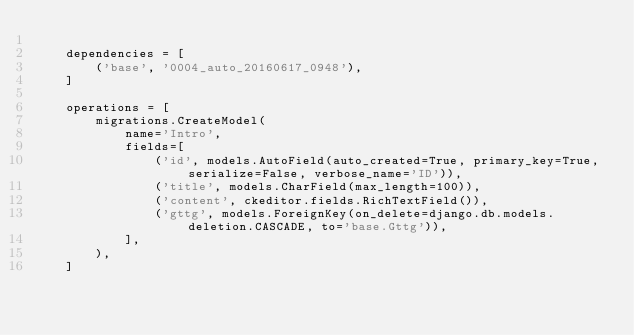Convert code to text. <code><loc_0><loc_0><loc_500><loc_500><_Python_>
    dependencies = [
        ('base', '0004_auto_20160617_0948'),
    ]

    operations = [
        migrations.CreateModel(
            name='Intro',
            fields=[
                ('id', models.AutoField(auto_created=True, primary_key=True, serialize=False, verbose_name='ID')),
                ('title', models.CharField(max_length=100)),
                ('content', ckeditor.fields.RichTextField()),
                ('gttg', models.ForeignKey(on_delete=django.db.models.deletion.CASCADE, to='base.Gttg')),
            ],
        ),
    ]
</code> 